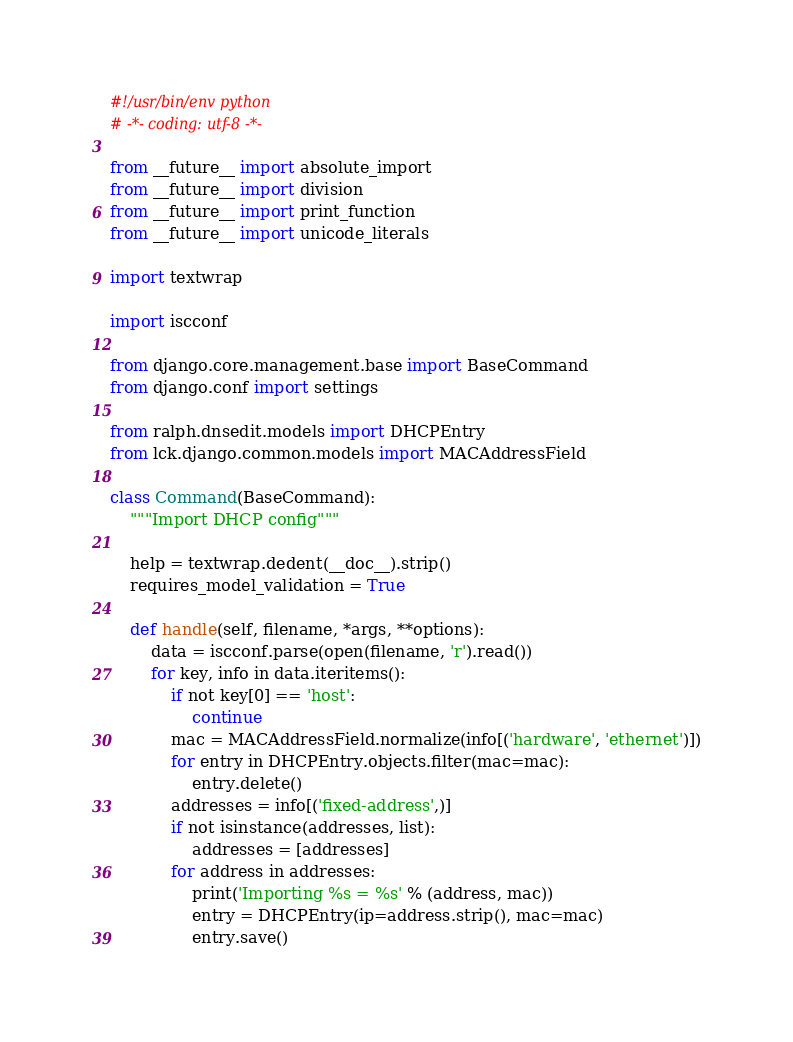Convert code to text. <code><loc_0><loc_0><loc_500><loc_500><_Python_>#!/usr/bin/env python
# -*- coding: utf-8 -*-

from __future__ import absolute_import
from __future__ import division
from __future__ import print_function
from __future__ import unicode_literals

import textwrap

import iscconf

from django.core.management.base import BaseCommand
from django.conf import settings

from ralph.dnsedit.models import DHCPEntry
from lck.django.common.models import MACAddressField

class Command(BaseCommand):
    """Import DHCP config"""

    help = textwrap.dedent(__doc__).strip()
    requires_model_validation = True

    def handle(self, filename, *args, **options):
        data = iscconf.parse(open(filename, 'r').read())
        for key, info in data.iteritems():
            if not key[0] == 'host':
                continue
            mac = MACAddressField.normalize(info[('hardware', 'ethernet')])
            for entry in DHCPEntry.objects.filter(mac=mac):
                entry.delete()
            addresses = info[('fixed-address',)]
            if not isinstance(addresses, list):
                addresses = [addresses]
            for address in addresses:
                print('Importing %s = %s' % (address, mac))
                entry = DHCPEntry(ip=address.strip(), mac=mac)
                entry.save()

</code> 